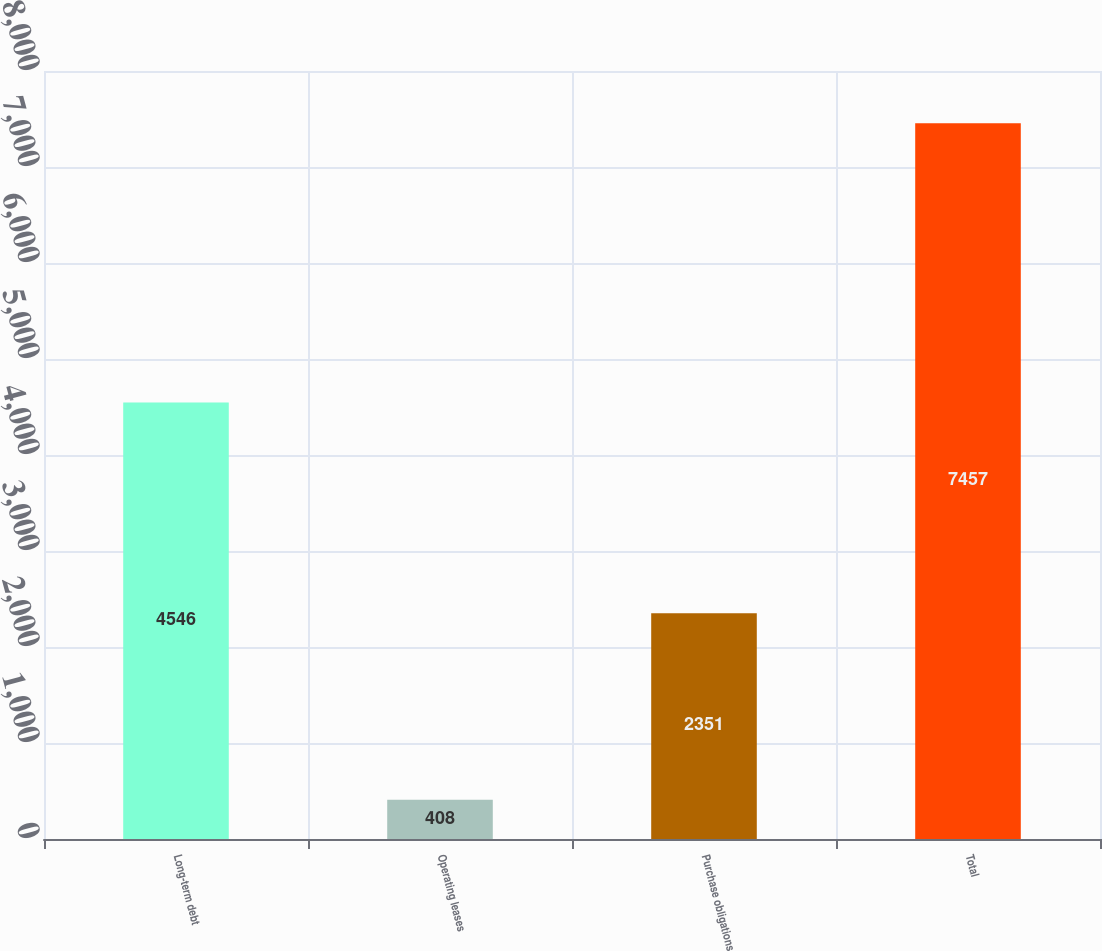<chart> <loc_0><loc_0><loc_500><loc_500><bar_chart><fcel>Long-term debt<fcel>Operating leases<fcel>Purchase obligations<fcel>Total<nl><fcel>4546<fcel>408<fcel>2351<fcel>7457<nl></chart> 